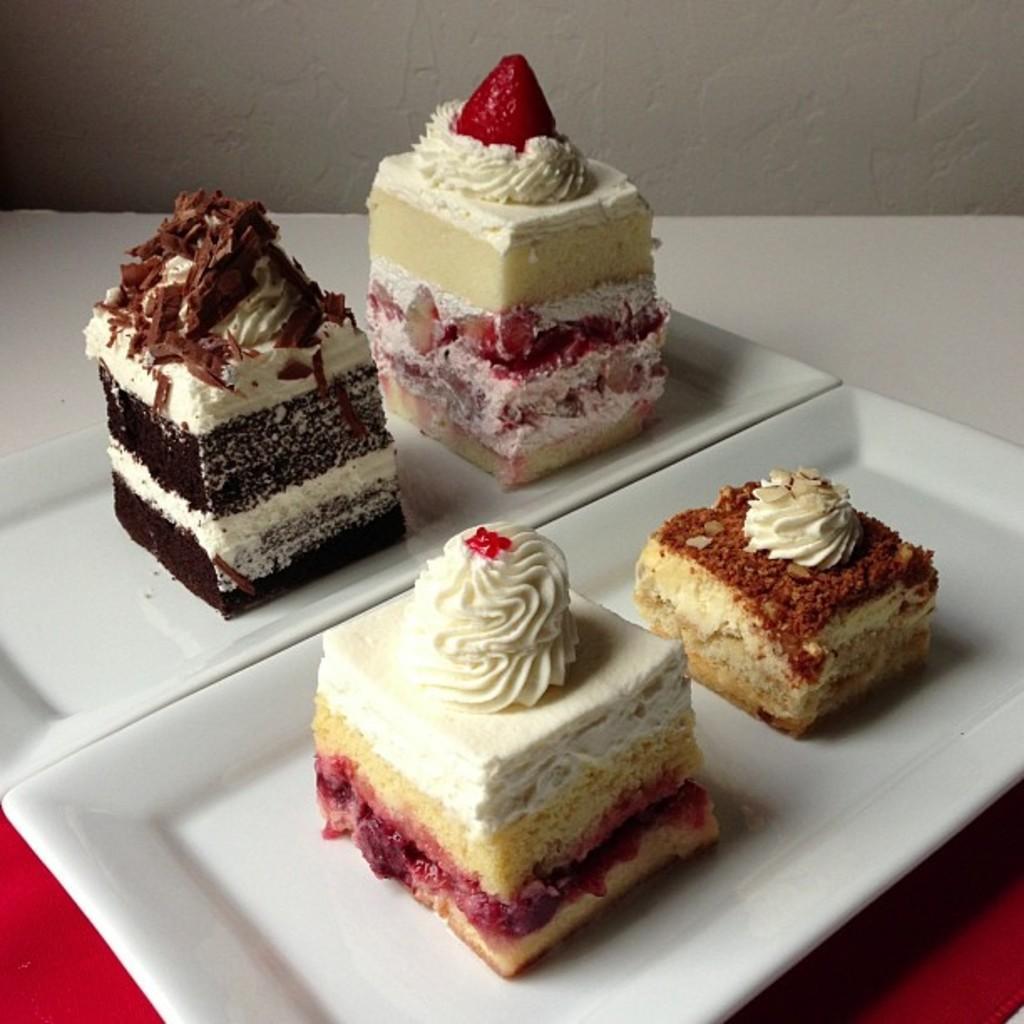How would you summarize this image in a sentence or two? In this picture we can see four cake pieces placed on white plates and these plates are placed on a red cloth and in the background we can see the wall. 